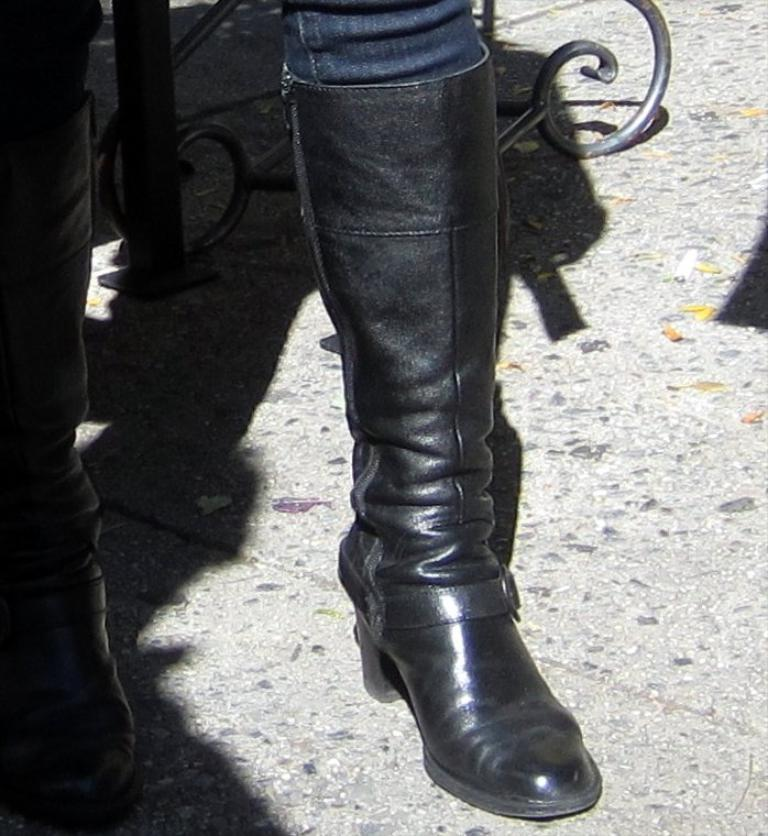What part of the body is visible in the image? There are legs visible in the image. Where are the legs located? The legs are on the floor. What can be seen behind the legs? There is an object behind the legs. What stage of development is the baby going through in the image? There is no baby present in the image, only legs are visible. 